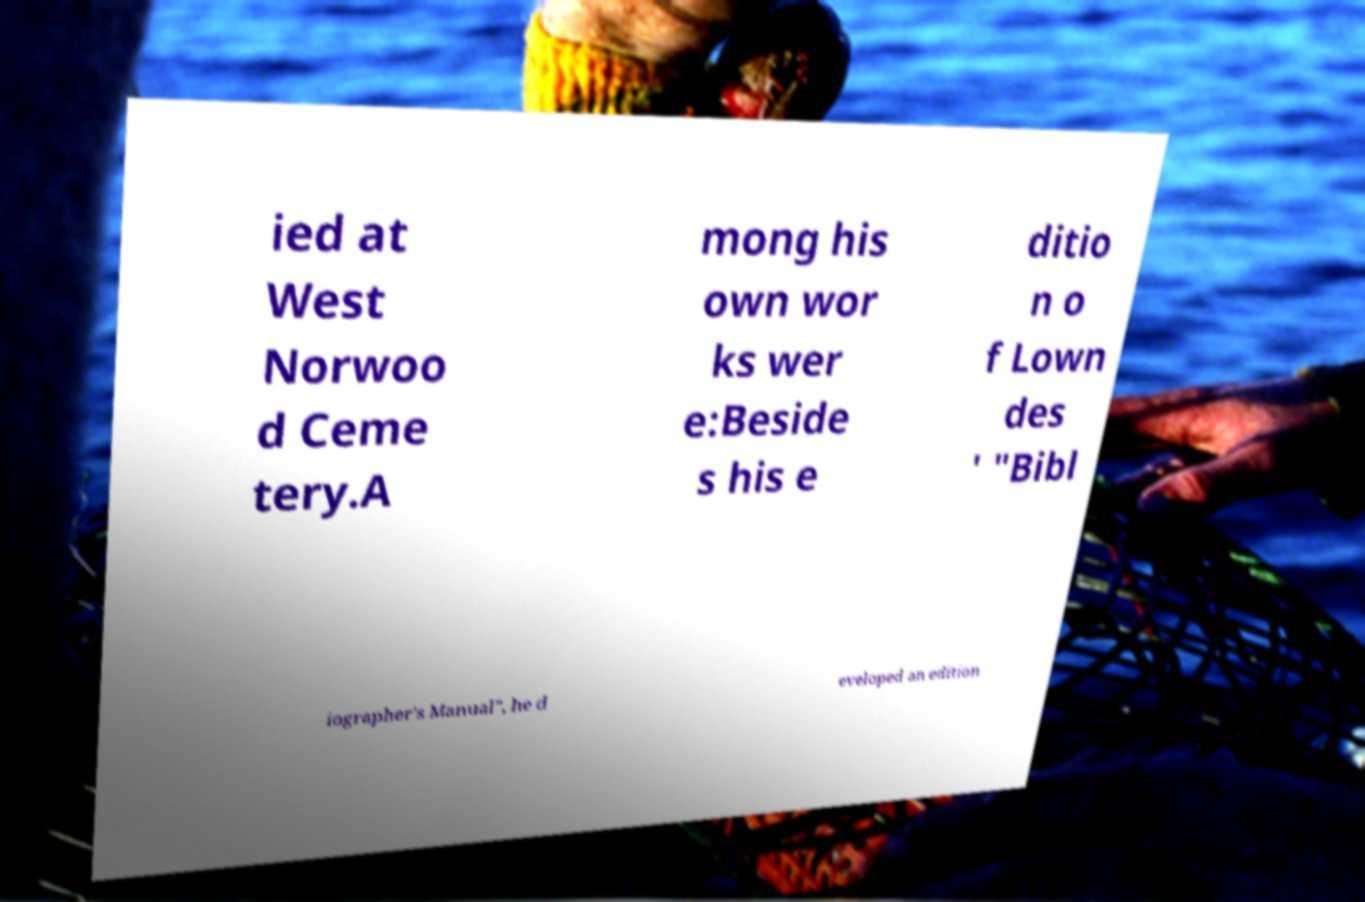I need the written content from this picture converted into text. Can you do that? ied at West Norwoo d Ceme tery.A mong his own wor ks wer e:Beside s his e ditio n o f Lown des ' "Bibl iographer's Manual", he d eveloped an edition 